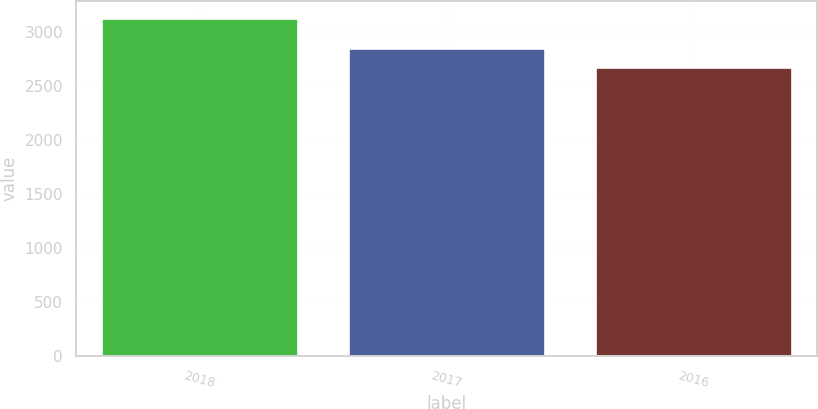Convert chart. <chart><loc_0><loc_0><loc_500><loc_500><bar_chart><fcel>2018<fcel>2017<fcel>2016<nl><fcel>3129.9<fcel>2854.9<fcel>2677.8<nl></chart> 